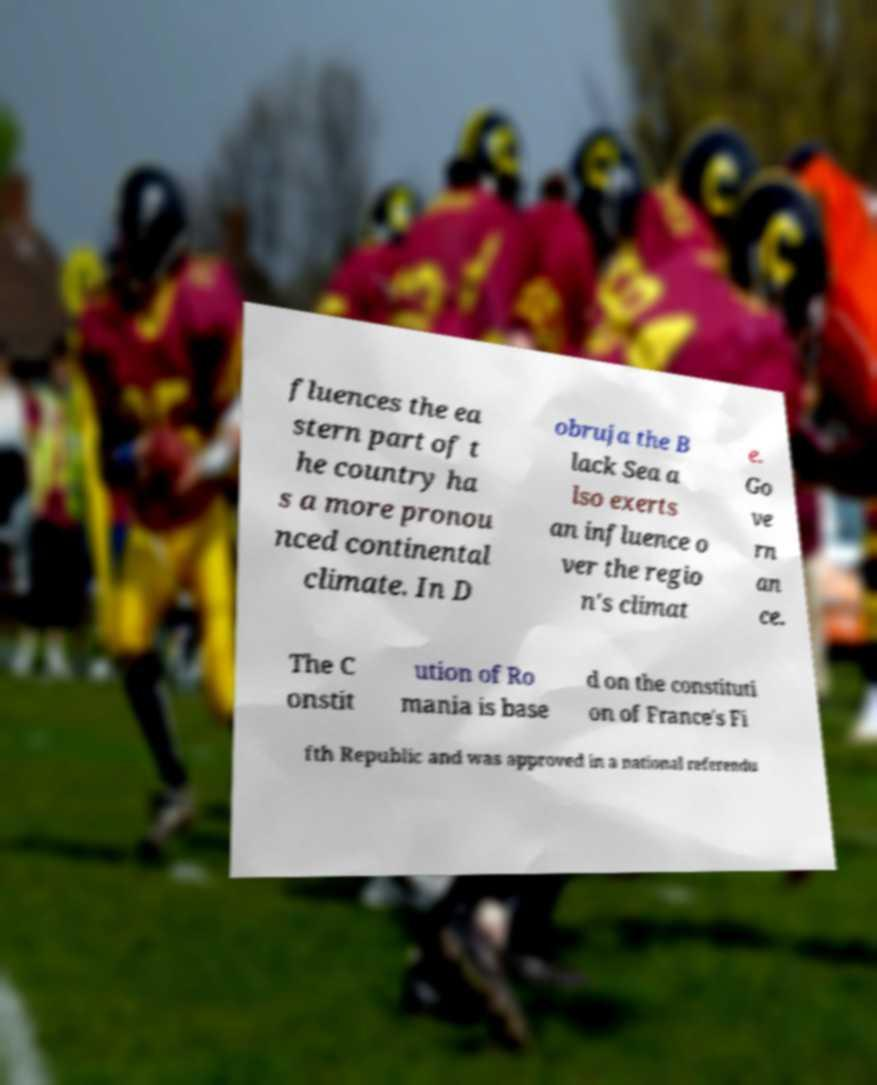Please read and relay the text visible in this image. What does it say? fluences the ea stern part of t he country ha s a more pronou nced continental climate. In D obruja the B lack Sea a lso exerts an influence o ver the regio n's climat e. Go ve rn an ce. The C onstit ution of Ro mania is base d on the constituti on of France's Fi fth Republic and was approved in a national referendu 